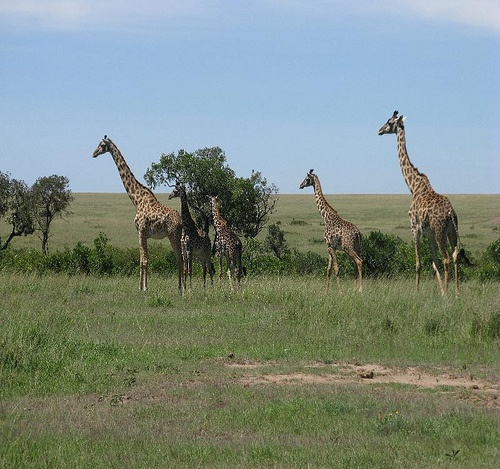Describe the objects in this image and their specific colors. I can see giraffe in lightgray, black, gray, and darkgreen tones, giraffe in lightgray, black, and gray tones, giraffe in lightgray, gray, and black tones, giraffe in lightgray, black, gray, darkgreen, and darkgray tones, and giraffe in lightgray, black, gray, and darkgray tones in this image. 